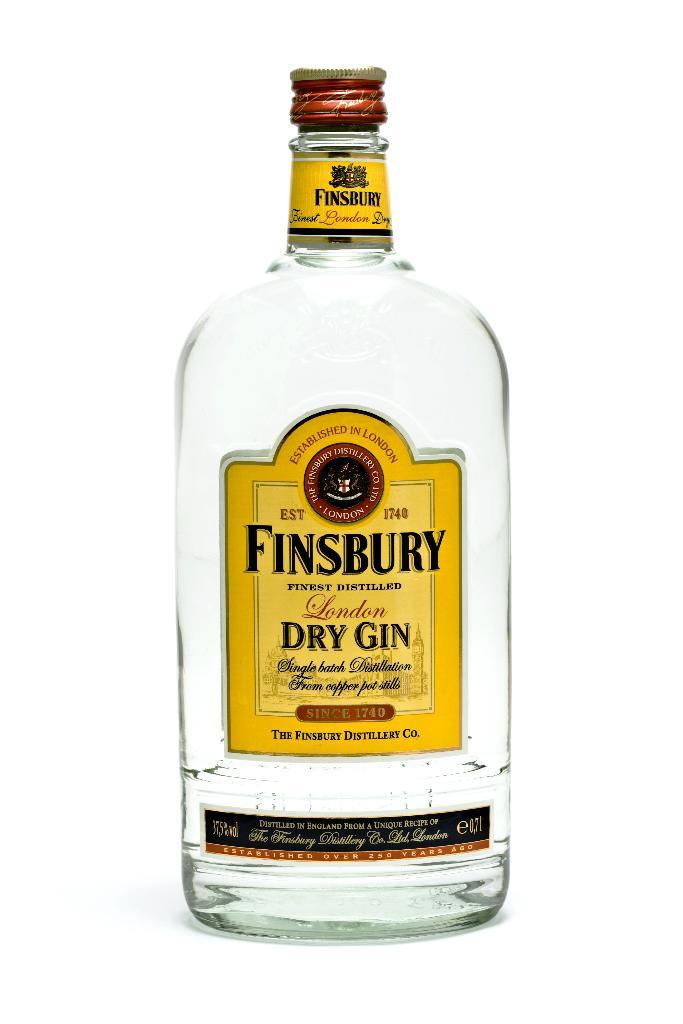Provide a one-sentence caption for the provided image. Large clear bottle of Finsbury Dry Gin made in London by the Finsbury Distillery Co. 